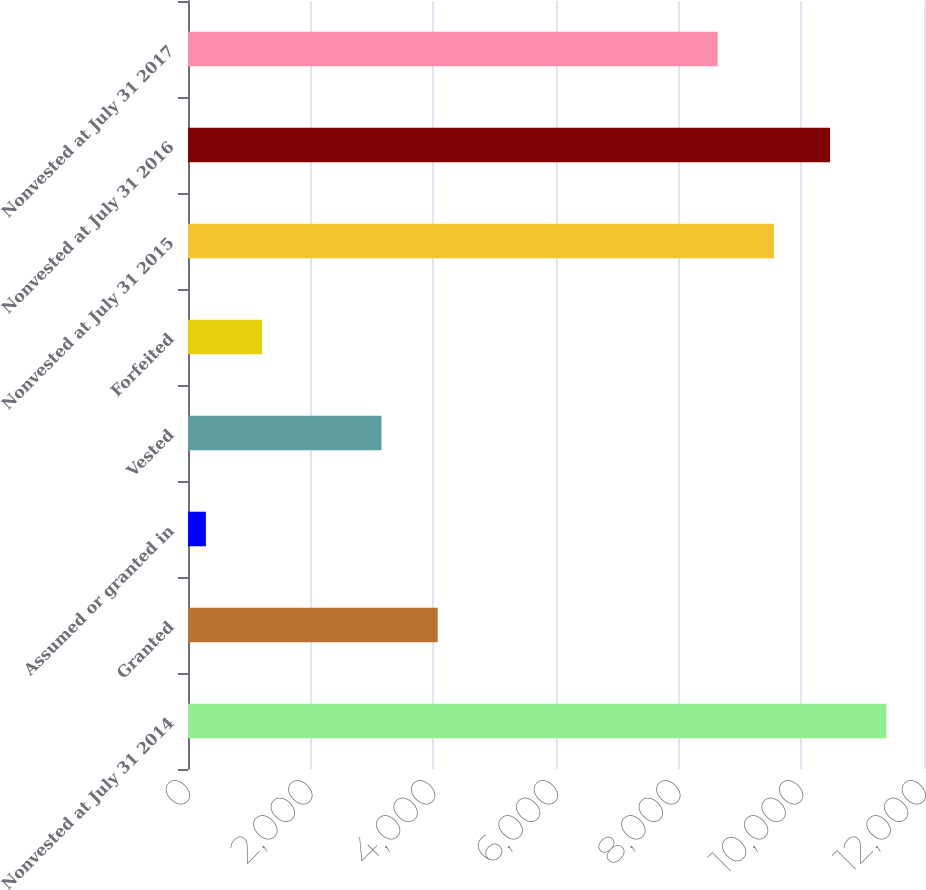Convert chart to OTSL. <chart><loc_0><loc_0><loc_500><loc_500><bar_chart><fcel>Nonvested at July 31 2014<fcel>Granted<fcel>Assumed or granted in<fcel>Vested<fcel>Forfeited<fcel>Nonvested at July 31 2015<fcel>Nonvested at July 31 2016<fcel>Nonvested at July 31 2017<nl><fcel>11384.9<fcel>4071.3<fcel>292<fcel>3155<fcel>1208.3<fcel>9552.3<fcel>10468.6<fcel>8636<nl></chart> 